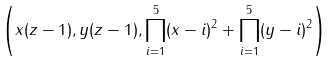Convert formula to latex. <formula><loc_0><loc_0><loc_500><loc_500>\left ( x ( z - 1 ) , y ( z - 1 ) , \prod ^ { 5 } _ { i = 1 } ( x - i ) ^ { 2 } + \prod ^ { 5 } _ { i = 1 } ( y - i ) ^ { 2 } \right )</formula> 